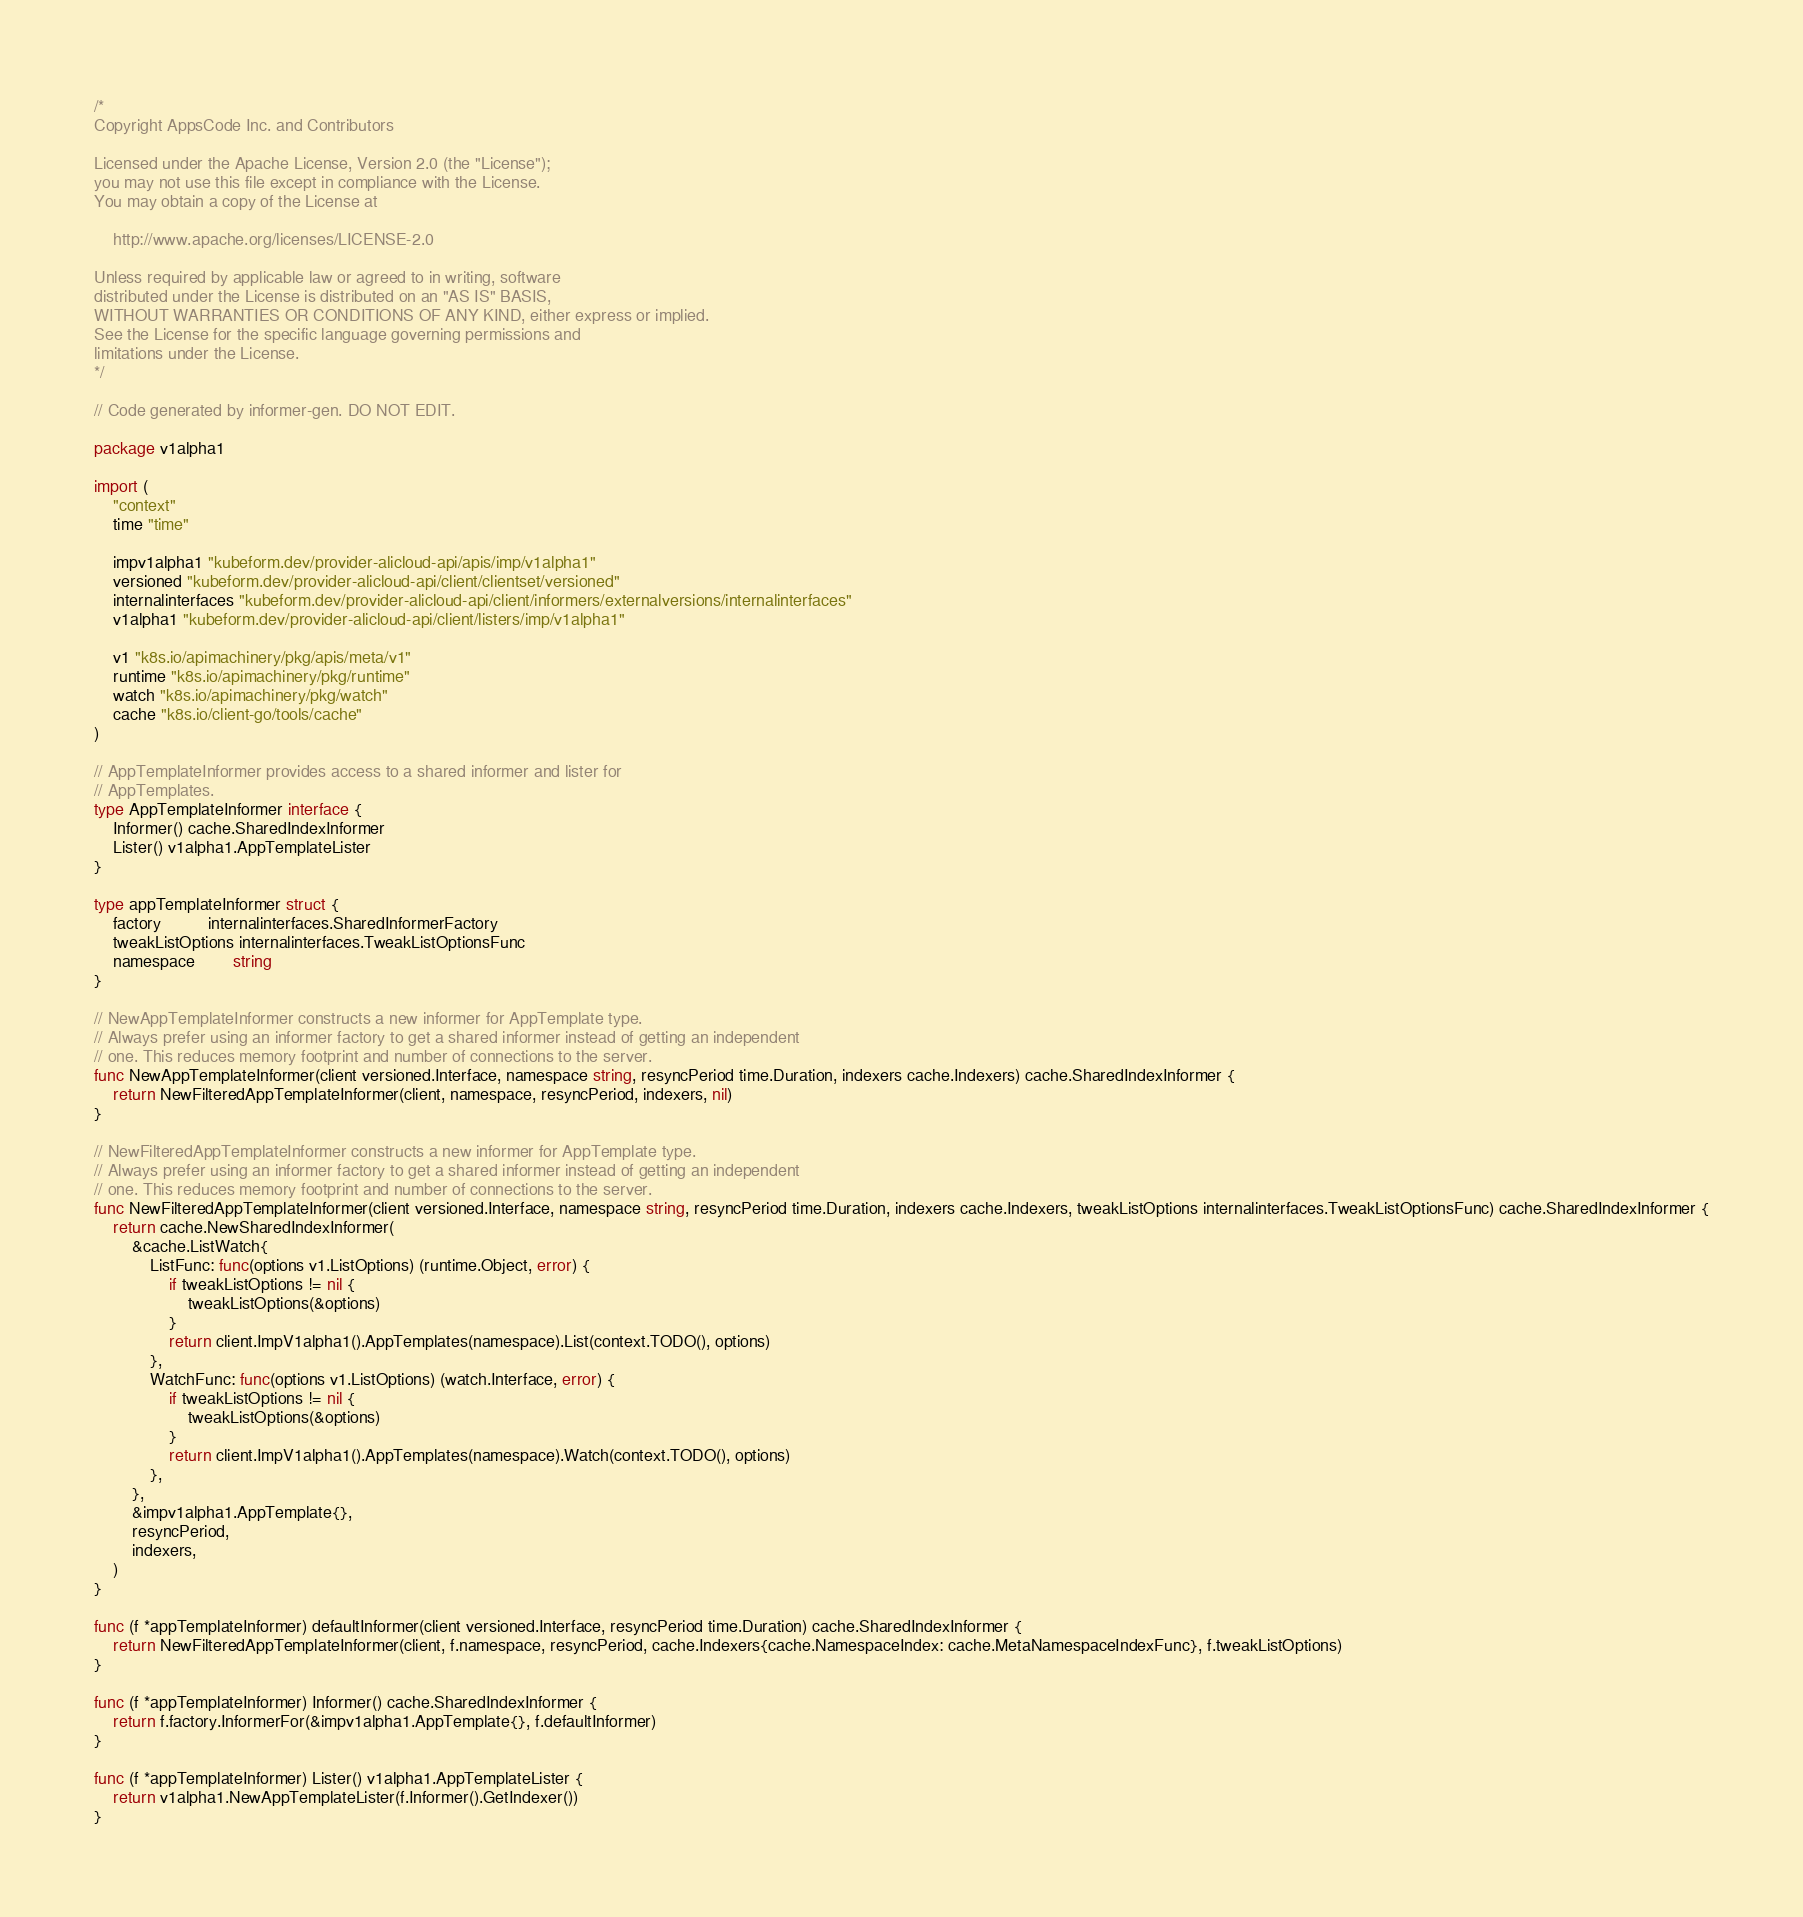Convert code to text. <code><loc_0><loc_0><loc_500><loc_500><_Go_>/*
Copyright AppsCode Inc. and Contributors

Licensed under the Apache License, Version 2.0 (the "License");
you may not use this file except in compliance with the License.
You may obtain a copy of the License at

    http://www.apache.org/licenses/LICENSE-2.0

Unless required by applicable law or agreed to in writing, software
distributed under the License is distributed on an "AS IS" BASIS,
WITHOUT WARRANTIES OR CONDITIONS OF ANY KIND, either express or implied.
See the License for the specific language governing permissions and
limitations under the License.
*/

// Code generated by informer-gen. DO NOT EDIT.

package v1alpha1

import (
	"context"
	time "time"

	impv1alpha1 "kubeform.dev/provider-alicloud-api/apis/imp/v1alpha1"
	versioned "kubeform.dev/provider-alicloud-api/client/clientset/versioned"
	internalinterfaces "kubeform.dev/provider-alicloud-api/client/informers/externalversions/internalinterfaces"
	v1alpha1 "kubeform.dev/provider-alicloud-api/client/listers/imp/v1alpha1"

	v1 "k8s.io/apimachinery/pkg/apis/meta/v1"
	runtime "k8s.io/apimachinery/pkg/runtime"
	watch "k8s.io/apimachinery/pkg/watch"
	cache "k8s.io/client-go/tools/cache"
)

// AppTemplateInformer provides access to a shared informer and lister for
// AppTemplates.
type AppTemplateInformer interface {
	Informer() cache.SharedIndexInformer
	Lister() v1alpha1.AppTemplateLister
}

type appTemplateInformer struct {
	factory          internalinterfaces.SharedInformerFactory
	tweakListOptions internalinterfaces.TweakListOptionsFunc
	namespace        string
}

// NewAppTemplateInformer constructs a new informer for AppTemplate type.
// Always prefer using an informer factory to get a shared informer instead of getting an independent
// one. This reduces memory footprint and number of connections to the server.
func NewAppTemplateInformer(client versioned.Interface, namespace string, resyncPeriod time.Duration, indexers cache.Indexers) cache.SharedIndexInformer {
	return NewFilteredAppTemplateInformer(client, namespace, resyncPeriod, indexers, nil)
}

// NewFilteredAppTemplateInformer constructs a new informer for AppTemplate type.
// Always prefer using an informer factory to get a shared informer instead of getting an independent
// one. This reduces memory footprint and number of connections to the server.
func NewFilteredAppTemplateInformer(client versioned.Interface, namespace string, resyncPeriod time.Duration, indexers cache.Indexers, tweakListOptions internalinterfaces.TweakListOptionsFunc) cache.SharedIndexInformer {
	return cache.NewSharedIndexInformer(
		&cache.ListWatch{
			ListFunc: func(options v1.ListOptions) (runtime.Object, error) {
				if tweakListOptions != nil {
					tweakListOptions(&options)
				}
				return client.ImpV1alpha1().AppTemplates(namespace).List(context.TODO(), options)
			},
			WatchFunc: func(options v1.ListOptions) (watch.Interface, error) {
				if tweakListOptions != nil {
					tweakListOptions(&options)
				}
				return client.ImpV1alpha1().AppTemplates(namespace).Watch(context.TODO(), options)
			},
		},
		&impv1alpha1.AppTemplate{},
		resyncPeriod,
		indexers,
	)
}

func (f *appTemplateInformer) defaultInformer(client versioned.Interface, resyncPeriod time.Duration) cache.SharedIndexInformer {
	return NewFilteredAppTemplateInformer(client, f.namespace, resyncPeriod, cache.Indexers{cache.NamespaceIndex: cache.MetaNamespaceIndexFunc}, f.tweakListOptions)
}

func (f *appTemplateInformer) Informer() cache.SharedIndexInformer {
	return f.factory.InformerFor(&impv1alpha1.AppTemplate{}, f.defaultInformer)
}

func (f *appTemplateInformer) Lister() v1alpha1.AppTemplateLister {
	return v1alpha1.NewAppTemplateLister(f.Informer().GetIndexer())
}
</code> 